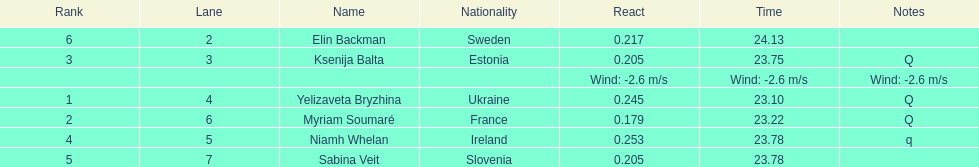Name of athlete who came in first in heat 1 of the women's 200 metres Yelizaveta Bryzhina. 